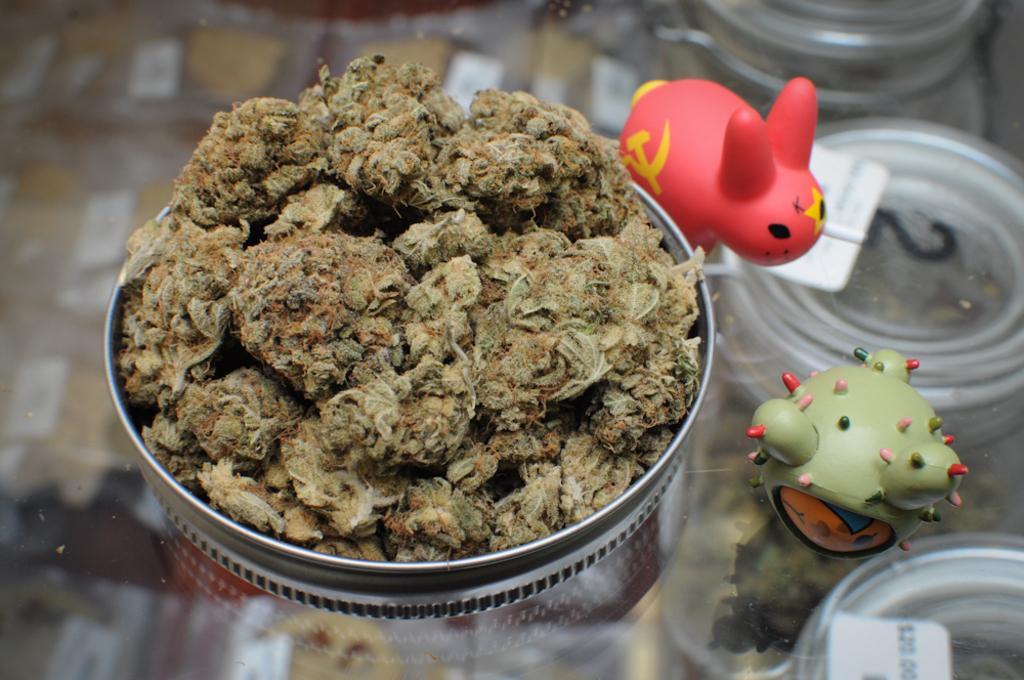How would you summarize this image in a sentence or two? In this image there is a plate on which there is weed. Beside the plate there are toys. The plate is kept on the glass table. 